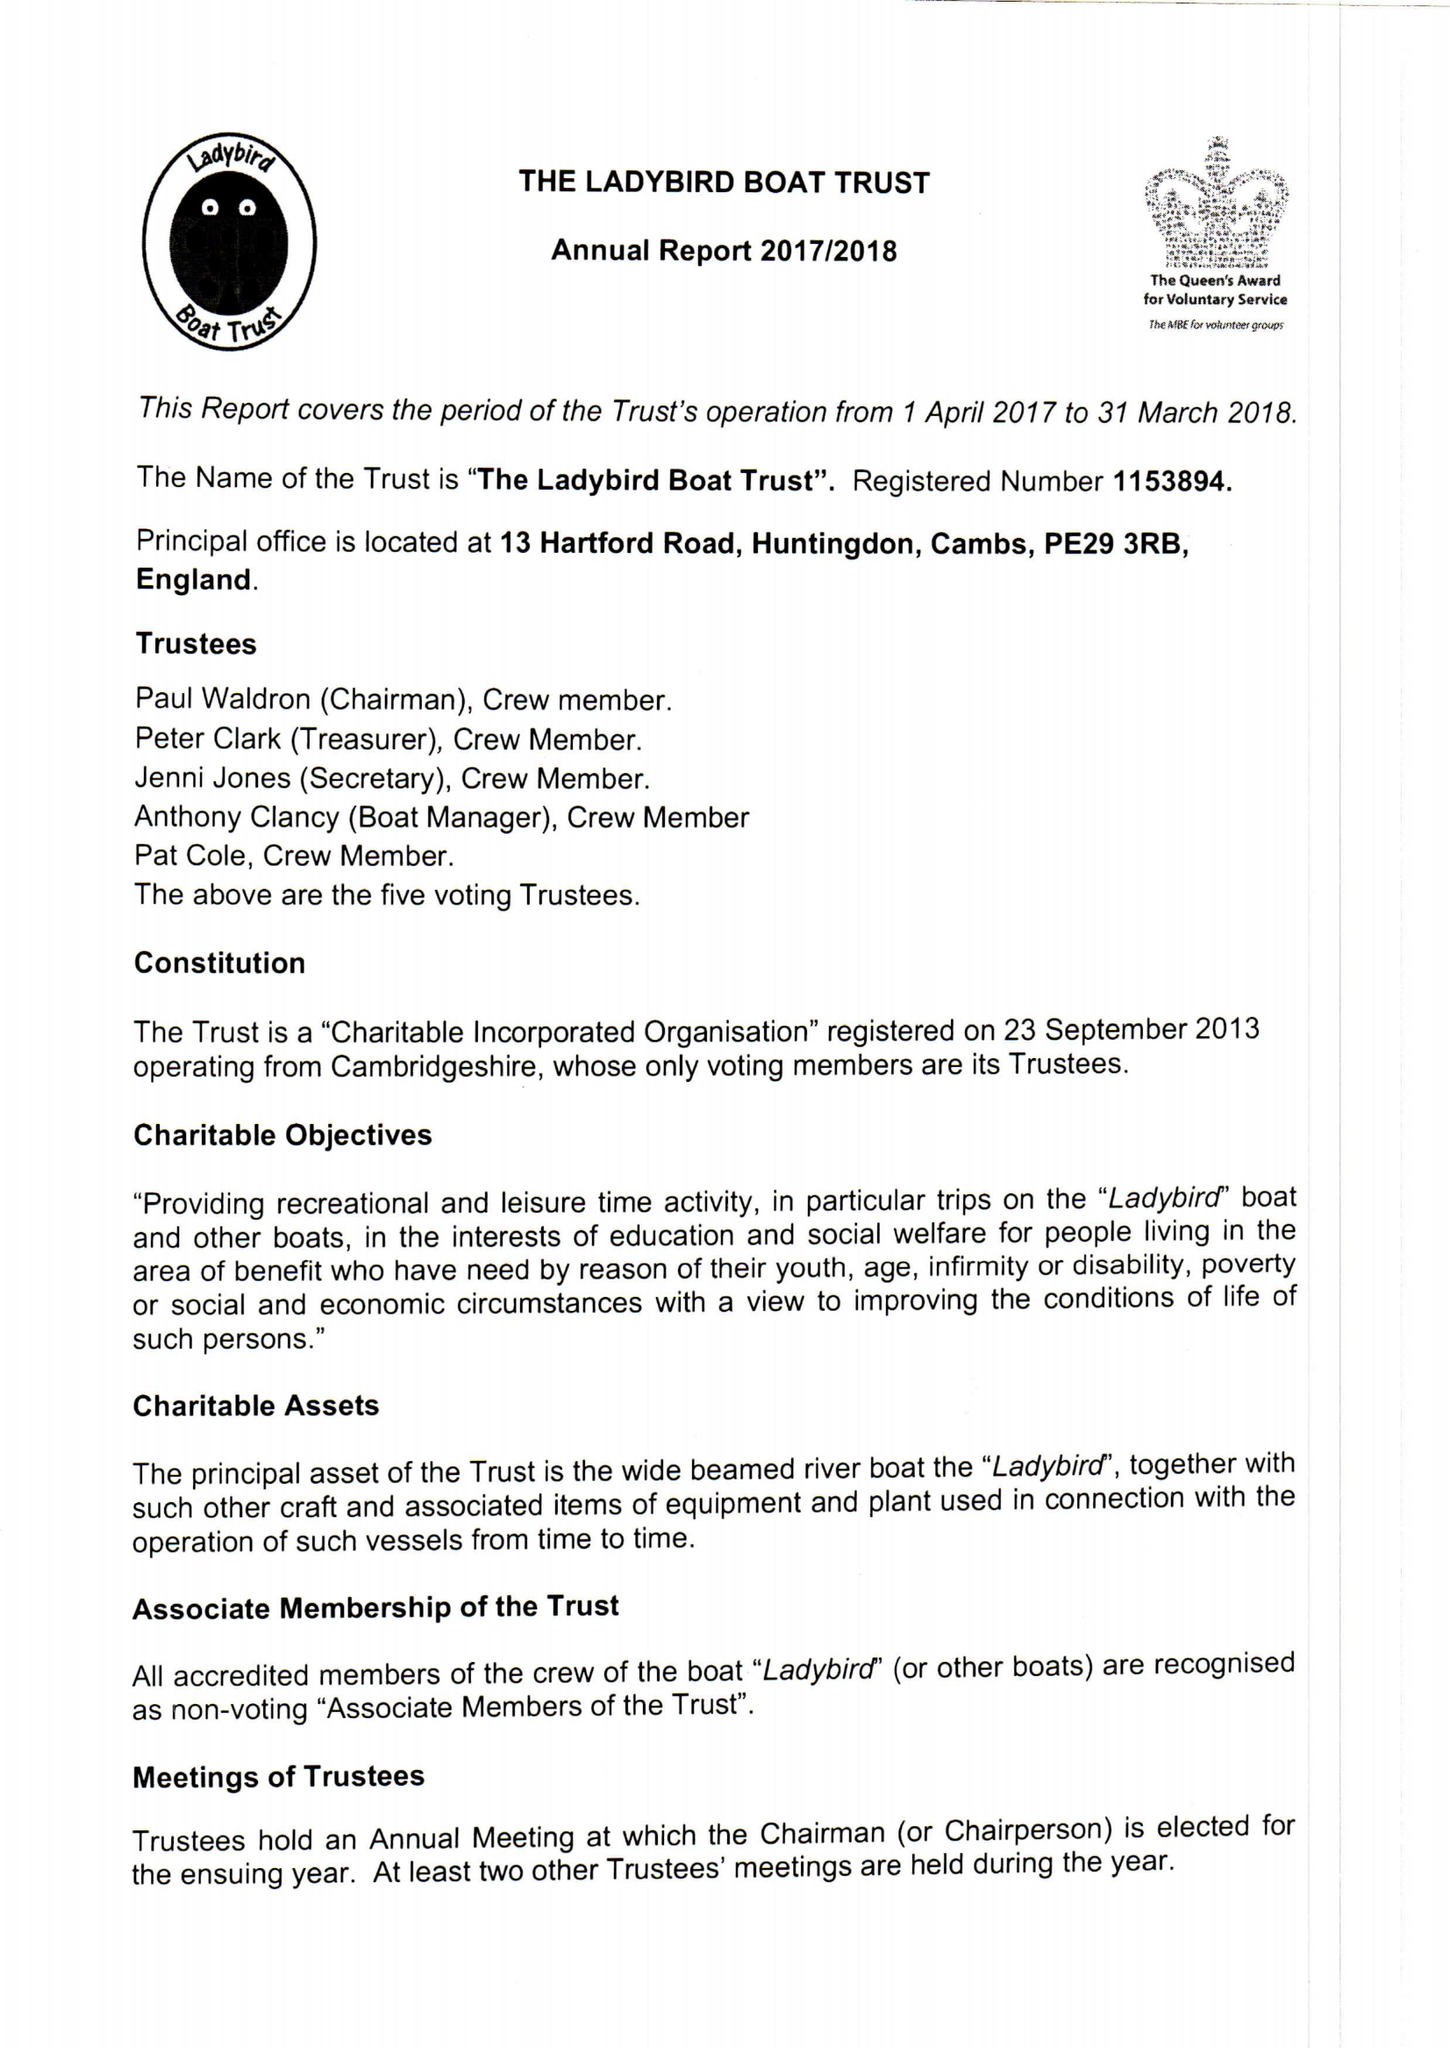What is the value for the income_annually_in_british_pounds?
Answer the question using a single word or phrase. 32906.00 